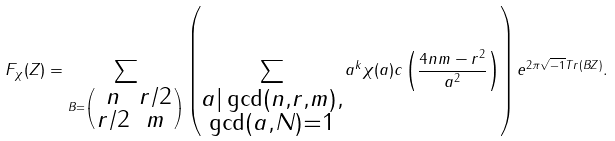Convert formula to latex. <formula><loc_0><loc_0><loc_500><loc_500>F _ { \chi } ( Z ) = \sum _ { B = \left ( \begin{smallmatrix} n & r / 2 \\ r / 2 & m \end{smallmatrix} \right ) } \left ( \sum _ { \substack { a | \gcd ( n , r , m ) , \\ \gcd ( a , N ) = 1 } } a ^ { k } \chi ( a ) c \left ( \frac { 4 n m - r ^ { 2 } } { a ^ { 2 } } \right ) \right ) e ^ { 2 \pi \sqrt { - 1 } T r ( B Z ) } .</formula> 